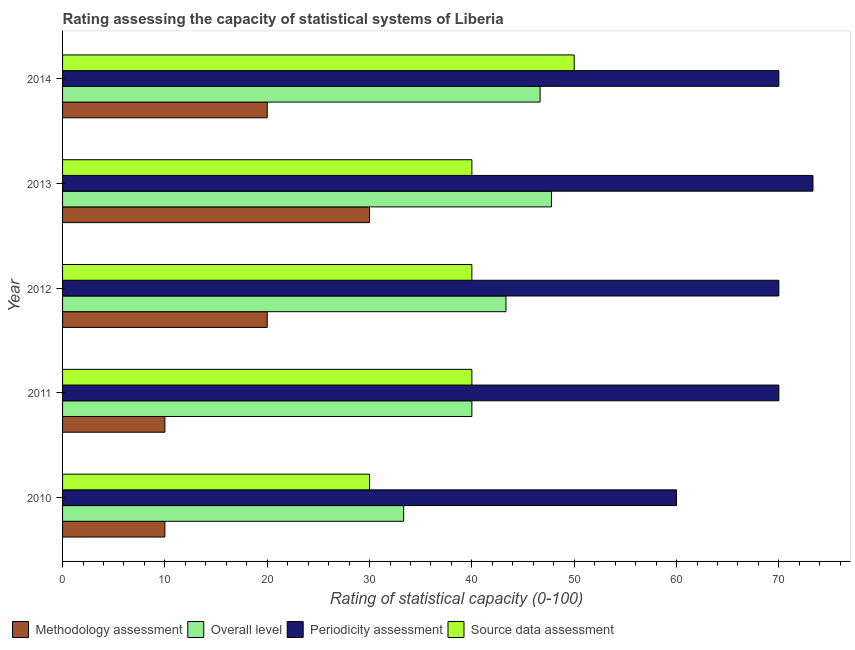How many different coloured bars are there?
Ensure brevity in your answer.  4. How many groups of bars are there?
Your answer should be compact. 5. How many bars are there on the 5th tick from the top?
Ensure brevity in your answer.  4. How many bars are there on the 4th tick from the bottom?
Give a very brief answer. 4. What is the methodology assessment rating in 2010?
Provide a short and direct response. 10. Across all years, what is the maximum source data assessment rating?
Offer a terse response. 50. Across all years, what is the minimum methodology assessment rating?
Your answer should be very brief. 10. In which year was the methodology assessment rating maximum?
Offer a very short reply. 2013. What is the total periodicity assessment rating in the graph?
Give a very brief answer. 343.33. What is the difference between the overall level rating in 2011 and that in 2012?
Keep it short and to the point. -3.33. What is the difference between the overall level rating in 2010 and the source data assessment rating in 2014?
Keep it short and to the point. -16.67. What is the average periodicity assessment rating per year?
Your answer should be compact. 68.67. In how many years, is the methodology assessment rating greater than 20 ?
Keep it short and to the point. 1. What is the ratio of the methodology assessment rating in 2011 to that in 2012?
Your answer should be very brief. 0.5. Is the periodicity assessment rating in 2010 less than that in 2014?
Provide a short and direct response. Yes. Is the difference between the periodicity assessment rating in 2011 and 2012 greater than the difference between the overall level rating in 2011 and 2012?
Your answer should be very brief. Yes. What is the difference between the highest and the lowest source data assessment rating?
Keep it short and to the point. 20. What does the 1st bar from the top in 2012 represents?
Provide a short and direct response. Source data assessment. What does the 4th bar from the bottom in 2010 represents?
Provide a succinct answer. Source data assessment. How many bars are there?
Offer a terse response. 20. Does the graph contain any zero values?
Your response must be concise. No. What is the title of the graph?
Give a very brief answer. Rating assessing the capacity of statistical systems of Liberia. Does "Tertiary schools" appear as one of the legend labels in the graph?
Your response must be concise. No. What is the label or title of the X-axis?
Your answer should be very brief. Rating of statistical capacity (0-100). What is the label or title of the Y-axis?
Ensure brevity in your answer.  Year. What is the Rating of statistical capacity (0-100) in Overall level in 2010?
Keep it short and to the point. 33.33. What is the Rating of statistical capacity (0-100) of Methodology assessment in 2011?
Your answer should be very brief. 10. What is the Rating of statistical capacity (0-100) in Overall level in 2011?
Offer a terse response. 40. What is the Rating of statistical capacity (0-100) in Periodicity assessment in 2011?
Your answer should be compact. 70. What is the Rating of statistical capacity (0-100) in Methodology assessment in 2012?
Provide a short and direct response. 20. What is the Rating of statistical capacity (0-100) of Overall level in 2012?
Your answer should be compact. 43.33. What is the Rating of statistical capacity (0-100) in Methodology assessment in 2013?
Make the answer very short. 30. What is the Rating of statistical capacity (0-100) in Overall level in 2013?
Your answer should be compact. 47.78. What is the Rating of statistical capacity (0-100) of Periodicity assessment in 2013?
Make the answer very short. 73.33. What is the Rating of statistical capacity (0-100) of Source data assessment in 2013?
Your response must be concise. 40. What is the Rating of statistical capacity (0-100) in Methodology assessment in 2014?
Provide a short and direct response. 20. What is the Rating of statistical capacity (0-100) in Overall level in 2014?
Provide a succinct answer. 46.67. What is the Rating of statistical capacity (0-100) in Periodicity assessment in 2014?
Ensure brevity in your answer.  70. What is the Rating of statistical capacity (0-100) of Source data assessment in 2014?
Your answer should be compact. 50. Across all years, what is the maximum Rating of statistical capacity (0-100) in Overall level?
Provide a succinct answer. 47.78. Across all years, what is the maximum Rating of statistical capacity (0-100) in Periodicity assessment?
Your answer should be very brief. 73.33. Across all years, what is the minimum Rating of statistical capacity (0-100) in Methodology assessment?
Your response must be concise. 10. Across all years, what is the minimum Rating of statistical capacity (0-100) of Overall level?
Your answer should be compact. 33.33. Across all years, what is the minimum Rating of statistical capacity (0-100) of Periodicity assessment?
Offer a very short reply. 60. What is the total Rating of statistical capacity (0-100) in Overall level in the graph?
Ensure brevity in your answer.  211.11. What is the total Rating of statistical capacity (0-100) in Periodicity assessment in the graph?
Keep it short and to the point. 343.33. What is the difference between the Rating of statistical capacity (0-100) in Overall level in 2010 and that in 2011?
Give a very brief answer. -6.67. What is the difference between the Rating of statistical capacity (0-100) in Periodicity assessment in 2010 and that in 2011?
Your answer should be very brief. -10. What is the difference between the Rating of statistical capacity (0-100) of Periodicity assessment in 2010 and that in 2012?
Keep it short and to the point. -10. What is the difference between the Rating of statistical capacity (0-100) in Methodology assessment in 2010 and that in 2013?
Ensure brevity in your answer.  -20. What is the difference between the Rating of statistical capacity (0-100) of Overall level in 2010 and that in 2013?
Your response must be concise. -14.44. What is the difference between the Rating of statistical capacity (0-100) in Periodicity assessment in 2010 and that in 2013?
Keep it short and to the point. -13.33. What is the difference between the Rating of statistical capacity (0-100) of Overall level in 2010 and that in 2014?
Offer a very short reply. -13.33. What is the difference between the Rating of statistical capacity (0-100) of Periodicity assessment in 2010 and that in 2014?
Make the answer very short. -10. What is the difference between the Rating of statistical capacity (0-100) in Overall level in 2011 and that in 2012?
Offer a very short reply. -3.33. What is the difference between the Rating of statistical capacity (0-100) in Source data assessment in 2011 and that in 2012?
Your answer should be very brief. 0. What is the difference between the Rating of statistical capacity (0-100) in Methodology assessment in 2011 and that in 2013?
Provide a succinct answer. -20. What is the difference between the Rating of statistical capacity (0-100) in Overall level in 2011 and that in 2013?
Offer a very short reply. -7.78. What is the difference between the Rating of statistical capacity (0-100) of Source data assessment in 2011 and that in 2013?
Provide a short and direct response. 0. What is the difference between the Rating of statistical capacity (0-100) in Overall level in 2011 and that in 2014?
Your response must be concise. -6.67. What is the difference between the Rating of statistical capacity (0-100) of Methodology assessment in 2012 and that in 2013?
Your response must be concise. -10. What is the difference between the Rating of statistical capacity (0-100) in Overall level in 2012 and that in 2013?
Provide a succinct answer. -4.44. What is the difference between the Rating of statistical capacity (0-100) of Source data assessment in 2012 and that in 2013?
Your answer should be compact. 0. What is the difference between the Rating of statistical capacity (0-100) of Methodology assessment in 2012 and that in 2014?
Provide a short and direct response. 0. What is the difference between the Rating of statistical capacity (0-100) of Periodicity assessment in 2012 and that in 2014?
Provide a short and direct response. 0. What is the difference between the Rating of statistical capacity (0-100) in Source data assessment in 2012 and that in 2014?
Offer a terse response. -10. What is the difference between the Rating of statistical capacity (0-100) in Source data assessment in 2013 and that in 2014?
Make the answer very short. -10. What is the difference between the Rating of statistical capacity (0-100) of Methodology assessment in 2010 and the Rating of statistical capacity (0-100) of Overall level in 2011?
Keep it short and to the point. -30. What is the difference between the Rating of statistical capacity (0-100) in Methodology assessment in 2010 and the Rating of statistical capacity (0-100) in Periodicity assessment in 2011?
Provide a short and direct response. -60. What is the difference between the Rating of statistical capacity (0-100) of Methodology assessment in 2010 and the Rating of statistical capacity (0-100) of Source data assessment in 2011?
Keep it short and to the point. -30. What is the difference between the Rating of statistical capacity (0-100) of Overall level in 2010 and the Rating of statistical capacity (0-100) of Periodicity assessment in 2011?
Provide a short and direct response. -36.67. What is the difference between the Rating of statistical capacity (0-100) of Overall level in 2010 and the Rating of statistical capacity (0-100) of Source data assessment in 2011?
Offer a very short reply. -6.67. What is the difference between the Rating of statistical capacity (0-100) of Methodology assessment in 2010 and the Rating of statistical capacity (0-100) of Overall level in 2012?
Make the answer very short. -33.33. What is the difference between the Rating of statistical capacity (0-100) of Methodology assessment in 2010 and the Rating of statistical capacity (0-100) of Periodicity assessment in 2012?
Give a very brief answer. -60. What is the difference between the Rating of statistical capacity (0-100) in Methodology assessment in 2010 and the Rating of statistical capacity (0-100) in Source data assessment in 2012?
Your response must be concise. -30. What is the difference between the Rating of statistical capacity (0-100) in Overall level in 2010 and the Rating of statistical capacity (0-100) in Periodicity assessment in 2012?
Ensure brevity in your answer.  -36.67. What is the difference between the Rating of statistical capacity (0-100) of Overall level in 2010 and the Rating of statistical capacity (0-100) of Source data assessment in 2012?
Keep it short and to the point. -6.67. What is the difference between the Rating of statistical capacity (0-100) in Methodology assessment in 2010 and the Rating of statistical capacity (0-100) in Overall level in 2013?
Ensure brevity in your answer.  -37.78. What is the difference between the Rating of statistical capacity (0-100) in Methodology assessment in 2010 and the Rating of statistical capacity (0-100) in Periodicity assessment in 2013?
Give a very brief answer. -63.33. What is the difference between the Rating of statistical capacity (0-100) of Overall level in 2010 and the Rating of statistical capacity (0-100) of Periodicity assessment in 2013?
Keep it short and to the point. -40. What is the difference between the Rating of statistical capacity (0-100) of Overall level in 2010 and the Rating of statistical capacity (0-100) of Source data assessment in 2013?
Your answer should be very brief. -6.67. What is the difference between the Rating of statistical capacity (0-100) of Periodicity assessment in 2010 and the Rating of statistical capacity (0-100) of Source data assessment in 2013?
Offer a very short reply. 20. What is the difference between the Rating of statistical capacity (0-100) in Methodology assessment in 2010 and the Rating of statistical capacity (0-100) in Overall level in 2014?
Your answer should be compact. -36.67. What is the difference between the Rating of statistical capacity (0-100) of Methodology assessment in 2010 and the Rating of statistical capacity (0-100) of Periodicity assessment in 2014?
Your response must be concise. -60. What is the difference between the Rating of statistical capacity (0-100) in Overall level in 2010 and the Rating of statistical capacity (0-100) in Periodicity assessment in 2014?
Your answer should be very brief. -36.67. What is the difference between the Rating of statistical capacity (0-100) in Overall level in 2010 and the Rating of statistical capacity (0-100) in Source data assessment in 2014?
Provide a short and direct response. -16.67. What is the difference between the Rating of statistical capacity (0-100) in Periodicity assessment in 2010 and the Rating of statistical capacity (0-100) in Source data assessment in 2014?
Your answer should be compact. 10. What is the difference between the Rating of statistical capacity (0-100) in Methodology assessment in 2011 and the Rating of statistical capacity (0-100) in Overall level in 2012?
Give a very brief answer. -33.33. What is the difference between the Rating of statistical capacity (0-100) in Methodology assessment in 2011 and the Rating of statistical capacity (0-100) in Periodicity assessment in 2012?
Your answer should be compact. -60. What is the difference between the Rating of statistical capacity (0-100) of Overall level in 2011 and the Rating of statistical capacity (0-100) of Periodicity assessment in 2012?
Ensure brevity in your answer.  -30. What is the difference between the Rating of statistical capacity (0-100) in Overall level in 2011 and the Rating of statistical capacity (0-100) in Source data assessment in 2012?
Provide a succinct answer. 0. What is the difference between the Rating of statistical capacity (0-100) of Methodology assessment in 2011 and the Rating of statistical capacity (0-100) of Overall level in 2013?
Provide a succinct answer. -37.78. What is the difference between the Rating of statistical capacity (0-100) of Methodology assessment in 2011 and the Rating of statistical capacity (0-100) of Periodicity assessment in 2013?
Ensure brevity in your answer.  -63.33. What is the difference between the Rating of statistical capacity (0-100) in Overall level in 2011 and the Rating of statistical capacity (0-100) in Periodicity assessment in 2013?
Provide a short and direct response. -33.33. What is the difference between the Rating of statistical capacity (0-100) in Overall level in 2011 and the Rating of statistical capacity (0-100) in Source data assessment in 2013?
Your answer should be compact. 0. What is the difference between the Rating of statistical capacity (0-100) of Periodicity assessment in 2011 and the Rating of statistical capacity (0-100) of Source data assessment in 2013?
Offer a very short reply. 30. What is the difference between the Rating of statistical capacity (0-100) of Methodology assessment in 2011 and the Rating of statistical capacity (0-100) of Overall level in 2014?
Give a very brief answer. -36.67. What is the difference between the Rating of statistical capacity (0-100) of Methodology assessment in 2011 and the Rating of statistical capacity (0-100) of Periodicity assessment in 2014?
Your response must be concise. -60. What is the difference between the Rating of statistical capacity (0-100) of Overall level in 2011 and the Rating of statistical capacity (0-100) of Periodicity assessment in 2014?
Provide a short and direct response. -30. What is the difference between the Rating of statistical capacity (0-100) of Overall level in 2011 and the Rating of statistical capacity (0-100) of Source data assessment in 2014?
Your response must be concise. -10. What is the difference between the Rating of statistical capacity (0-100) of Periodicity assessment in 2011 and the Rating of statistical capacity (0-100) of Source data assessment in 2014?
Make the answer very short. 20. What is the difference between the Rating of statistical capacity (0-100) in Methodology assessment in 2012 and the Rating of statistical capacity (0-100) in Overall level in 2013?
Provide a short and direct response. -27.78. What is the difference between the Rating of statistical capacity (0-100) of Methodology assessment in 2012 and the Rating of statistical capacity (0-100) of Periodicity assessment in 2013?
Provide a succinct answer. -53.33. What is the difference between the Rating of statistical capacity (0-100) of Methodology assessment in 2012 and the Rating of statistical capacity (0-100) of Source data assessment in 2013?
Provide a succinct answer. -20. What is the difference between the Rating of statistical capacity (0-100) in Overall level in 2012 and the Rating of statistical capacity (0-100) in Source data assessment in 2013?
Keep it short and to the point. 3.33. What is the difference between the Rating of statistical capacity (0-100) in Periodicity assessment in 2012 and the Rating of statistical capacity (0-100) in Source data assessment in 2013?
Keep it short and to the point. 30. What is the difference between the Rating of statistical capacity (0-100) in Methodology assessment in 2012 and the Rating of statistical capacity (0-100) in Overall level in 2014?
Ensure brevity in your answer.  -26.67. What is the difference between the Rating of statistical capacity (0-100) in Overall level in 2012 and the Rating of statistical capacity (0-100) in Periodicity assessment in 2014?
Provide a short and direct response. -26.67. What is the difference between the Rating of statistical capacity (0-100) of Overall level in 2012 and the Rating of statistical capacity (0-100) of Source data assessment in 2014?
Ensure brevity in your answer.  -6.67. What is the difference between the Rating of statistical capacity (0-100) in Periodicity assessment in 2012 and the Rating of statistical capacity (0-100) in Source data assessment in 2014?
Give a very brief answer. 20. What is the difference between the Rating of statistical capacity (0-100) of Methodology assessment in 2013 and the Rating of statistical capacity (0-100) of Overall level in 2014?
Ensure brevity in your answer.  -16.67. What is the difference between the Rating of statistical capacity (0-100) in Methodology assessment in 2013 and the Rating of statistical capacity (0-100) in Source data assessment in 2014?
Your answer should be compact. -20. What is the difference between the Rating of statistical capacity (0-100) in Overall level in 2013 and the Rating of statistical capacity (0-100) in Periodicity assessment in 2014?
Your response must be concise. -22.22. What is the difference between the Rating of statistical capacity (0-100) in Overall level in 2013 and the Rating of statistical capacity (0-100) in Source data assessment in 2014?
Provide a succinct answer. -2.22. What is the difference between the Rating of statistical capacity (0-100) of Periodicity assessment in 2013 and the Rating of statistical capacity (0-100) of Source data assessment in 2014?
Provide a succinct answer. 23.33. What is the average Rating of statistical capacity (0-100) in Overall level per year?
Make the answer very short. 42.22. What is the average Rating of statistical capacity (0-100) in Periodicity assessment per year?
Your answer should be compact. 68.67. In the year 2010, what is the difference between the Rating of statistical capacity (0-100) of Methodology assessment and Rating of statistical capacity (0-100) of Overall level?
Ensure brevity in your answer.  -23.33. In the year 2010, what is the difference between the Rating of statistical capacity (0-100) of Methodology assessment and Rating of statistical capacity (0-100) of Source data assessment?
Offer a very short reply. -20. In the year 2010, what is the difference between the Rating of statistical capacity (0-100) of Overall level and Rating of statistical capacity (0-100) of Periodicity assessment?
Your answer should be very brief. -26.67. In the year 2010, what is the difference between the Rating of statistical capacity (0-100) in Periodicity assessment and Rating of statistical capacity (0-100) in Source data assessment?
Provide a succinct answer. 30. In the year 2011, what is the difference between the Rating of statistical capacity (0-100) of Methodology assessment and Rating of statistical capacity (0-100) of Overall level?
Offer a very short reply. -30. In the year 2011, what is the difference between the Rating of statistical capacity (0-100) of Methodology assessment and Rating of statistical capacity (0-100) of Periodicity assessment?
Keep it short and to the point. -60. In the year 2011, what is the difference between the Rating of statistical capacity (0-100) of Periodicity assessment and Rating of statistical capacity (0-100) of Source data assessment?
Give a very brief answer. 30. In the year 2012, what is the difference between the Rating of statistical capacity (0-100) of Methodology assessment and Rating of statistical capacity (0-100) of Overall level?
Provide a short and direct response. -23.33. In the year 2012, what is the difference between the Rating of statistical capacity (0-100) of Methodology assessment and Rating of statistical capacity (0-100) of Periodicity assessment?
Provide a succinct answer. -50. In the year 2012, what is the difference between the Rating of statistical capacity (0-100) of Overall level and Rating of statistical capacity (0-100) of Periodicity assessment?
Your response must be concise. -26.67. In the year 2012, what is the difference between the Rating of statistical capacity (0-100) of Overall level and Rating of statistical capacity (0-100) of Source data assessment?
Your response must be concise. 3.33. In the year 2013, what is the difference between the Rating of statistical capacity (0-100) in Methodology assessment and Rating of statistical capacity (0-100) in Overall level?
Provide a succinct answer. -17.78. In the year 2013, what is the difference between the Rating of statistical capacity (0-100) in Methodology assessment and Rating of statistical capacity (0-100) in Periodicity assessment?
Provide a short and direct response. -43.33. In the year 2013, what is the difference between the Rating of statistical capacity (0-100) in Methodology assessment and Rating of statistical capacity (0-100) in Source data assessment?
Your response must be concise. -10. In the year 2013, what is the difference between the Rating of statistical capacity (0-100) in Overall level and Rating of statistical capacity (0-100) in Periodicity assessment?
Provide a succinct answer. -25.56. In the year 2013, what is the difference between the Rating of statistical capacity (0-100) of Overall level and Rating of statistical capacity (0-100) of Source data assessment?
Ensure brevity in your answer.  7.78. In the year 2013, what is the difference between the Rating of statistical capacity (0-100) in Periodicity assessment and Rating of statistical capacity (0-100) in Source data assessment?
Keep it short and to the point. 33.33. In the year 2014, what is the difference between the Rating of statistical capacity (0-100) of Methodology assessment and Rating of statistical capacity (0-100) of Overall level?
Give a very brief answer. -26.67. In the year 2014, what is the difference between the Rating of statistical capacity (0-100) in Methodology assessment and Rating of statistical capacity (0-100) in Periodicity assessment?
Ensure brevity in your answer.  -50. In the year 2014, what is the difference between the Rating of statistical capacity (0-100) in Overall level and Rating of statistical capacity (0-100) in Periodicity assessment?
Keep it short and to the point. -23.33. What is the ratio of the Rating of statistical capacity (0-100) in Overall level in 2010 to that in 2011?
Ensure brevity in your answer.  0.83. What is the ratio of the Rating of statistical capacity (0-100) of Source data assessment in 2010 to that in 2011?
Provide a succinct answer. 0.75. What is the ratio of the Rating of statistical capacity (0-100) of Overall level in 2010 to that in 2012?
Make the answer very short. 0.77. What is the ratio of the Rating of statistical capacity (0-100) in Periodicity assessment in 2010 to that in 2012?
Provide a succinct answer. 0.86. What is the ratio of the Rating of statistical capacity (0-100) of Source data assessment in 2010 to that in 2012?
Make the answer very short. 0.75. What is the ratio of the Rating of statistical capacity (0-100) in Methodology assessment in 2010 to that in 2013?
Give a very brief answer. 0.33. What is the ratio of the Rating of statistical capacity (0-100) in Overall level in 2010 to that in 2013?
Offer a very short reply. 0.7. What is the ratio of the Rating of statistical capacity (0-100) in Periodicity assessment in 2010 to that in 2013?
Make the answer very short. 0.82. What is the ratio of the Rating of statistical capacity (0-100) in Source data assessment in 2010 to that in 2013?
Your answer should be very brief. 0.75. What is the ratio of the Rating of statistical capacity (0-100) in Overall level in 2010 to that in 2014?
Give a very brief answer. 0.71. What is the ratio of the Rating of statistical capacity (0-100) of Source data assessment in 2010 to that in 2014?
Your answer should be compact. 0.6. What is the ratio of the Rating of statistical capacity (0-100) in Methodology assessment in 2011 to that in 2012?
Keep it short and to the point. 0.5. What is the ratio of the Rating of statistical capacity (0-100) of Overall level in 2011 to that in 2012?
Your response must be concise. 0.92. What is the ratio of the Rating of statistical capacity (0-100) in Source data assessment in 2011 to that in 2012?
Offer a very short reply. 1. What is the ratio of the Rating of statistical capacity (0-100) of Overall level in 2011 to that in 2013?
Your answer should be compact. 0.84. What is the ratio of the Rating of statistical capacity (0-100) of Periodicity assessment in 2011 to that in 2013?
Ensure brevity in your answer.  0.95. What is the ratio of the Rating of statistical capacity (0-100) in Overall level in 2011 to that in 2014?
Give a very brief answer. 0.86. What is the ratio of the Rating of statistical capacity (0-100) of Source data assessment in 2011 to that in 2014?
Offer a terse response. 0.8. What is the ratio of the Rating of statistical capacity (0-100) in Methodology assessment in 2012 to that in 2013?
Offer a very short reply. 0.67. What is the ratio of the Rating of statistical capacity (0-100) in Overall level in 2012 to that in 2013?
Offer a very short reply. 0.91. What is the ratio of the Rating of statistical capacity (0-100) in Periodicity assessment in 2012 to that in 2013?
Provide a short and direct response. 0.95. What is the ratio of the Rating of statistical capacity (0-100) of Overall level in 2012 to that in 2014?
Give a very brief answer. 0.93. What is the ratio of the Rating of statistical capacity (0-100) of Methodology assessment in 2013 to that in 2014?
Ensure brevity in your answer.  1.5. What is the ratio of the Rating of statistical capacity (0-100) of Overall level in 2013 to that in 2014?
Provide a short and direct response. 1.02. What is the ratio of the Rating of statistical capacity (0-100) in Periodicity assessment in 2013 to that in 2014?
Your answer should be very brief. 1.05. What is the difference between the highest and the second highest Rating of statistical capacity (0-100) of Source data assessment?
Keep it short and to the point. 10. What is the difference between the highest and the lowest Rating of statistical capacity (0-100) of Overall level?
Give a very brief answer. 14.44. What is the difference between the highest and the lowest Rating of statistical capacity (0-100) of Periodicity assessment?
Offer a very short reply. 13.33. 